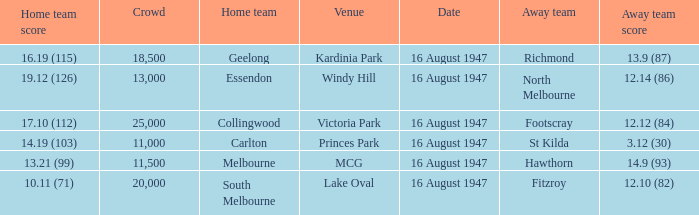What was the total size of the crowd when the away team scored 12.10 (82)? 20000.0. 